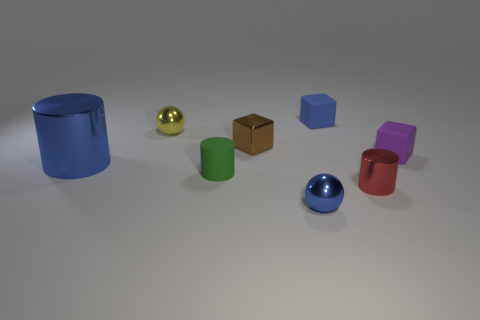Subtract all small purple rubber blocks. How many blocks are left? 2 Subtract all brown blocks. How many blocks are left? 2 Subtract all balls. How many objects are left? 6 Subtract 2 blocks. How many blocks are left? 1 Subtract all brown cylinders. Subtract all gray spheres. How many cylinders are left? 3 Subtract all brown cylinders. How many red blocks are left? 0 Subtract all green metal spheres. Subtract all small cylinders. How many objects are left? 6 Add 5 small metal balls. How many small metal balls are left? 7 Add 7 spheres. How many spheres exist? 9 Add 1 tiny brown blocks. How many objects exist? 9 